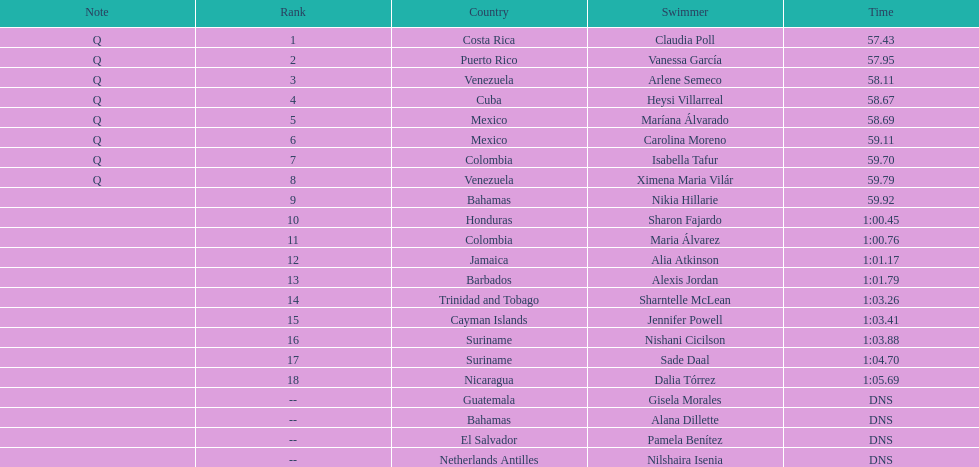Who completed after claudia poll? Vanessa García. Can you give me this table as a dict? {'header': ['Note', 'Rank', 'Country', 'Swimmer', 'Time'], 'rows': [['Q', '1', 'Costa Rica', 'Claudia Poll', '57.43'], ['Q', '2', 'Puerto Rico', 'Vanessa García', '57.95'], ['Q', '3', 'Venezuela', 'Arlene Semeco', '58.11'], ['Q', '4', 'Cuba', 'Heysi Villarreal', '58.67'], ['Q', '5', 'Mexico', 'Maríana Álvarado', '58.69'], ['Q', '6', 'Mexico', 'Carolina Moreno', '59.11'], ['Q', '7', 'Colombia', 'Isabella Tafur', '59.70'], ['Q', '8', 'Venezuela', 'Ximena Maria Vilár', '59.79'], ['', '9', 'Bahamas', 'Nikia Hillarie', '59.92'], ['', '10', 'Honduras', 'Sharon Fajardo', '1:00.45'], ['', '11', 'Colombia', 'Maria Álvarez', '1:00.76'], ['', '12', 'Jamaica', 'Alia Atkinson', '1:01.17'], ['', '13', 'Barbados', 'Alexis Jordan', '1:01.79'], ['', '14', 'Trinidad and Tobago', 'Sharntelle McLean', '1:03.26'], ['', '15', 'Cayman Islands', 'Jennifer Powell', '1:03.41'], ['', '16', 'Suriname', 'Nishani Cicilson', '1:03.88'], ['', '17', 'Suriname', 'Sade Daal', '1:04.70'], ['', '18', 'Nicaragua', 'Dalia Tórrez', '1:05.69'], ['', '--', 'Guatemala', 'Gisela Morales', 'DNS'], ['', '--', 'Bahamas', 'Alana Dillette', 'DNS'], ['', '--', 'El Salvador', 'Pamela Benítez', 'DNS'], ['', '--', 'Netherlands Antilles', 'Nilshaira Isenia', 'DNS']]} 